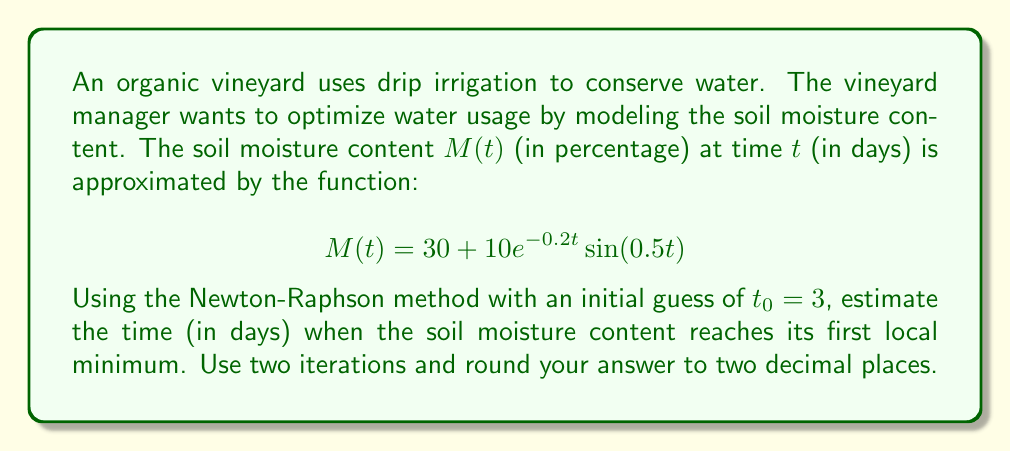Provide a solution to this math problem. To find the local minimum, we need to find where the derivative of $M(t)$ equals zero. Let's follow these steps:

1) First, we calculate $M'(t)$:
   $$M'(t) = 10e^{-0.2t}(0.5\cos(0.5t) - 0.2\sin(0.5t))$$

2) We want to find $t$ where $M'(t) = 0$. Let's define $f(t) = M'(t)$:
   $$f(t) = 10e^{-0.2t}(0.5\cos(0.5t) - 0.2\sin(0.5t))$$

3) We also need $f'(t)$:
   $$f'(t) = 10e^{-0.2t}(-0.2(0.5\cos(0.5t) - 0.2\sin(0.5t)) + (-0.25\sin(0.5t) - 0.1\cos(0.5t)))$$

4) The Newton-Raphson formula is:
   $$t_{n+1} = t_n - \frac{f(t_n)}{f'(t_n)}$$

5) First iteration:
   $t_0 = 3$
   $f(3) = 10e^{-0.6}(0.5\cos(1.5) - 0.2\sin(1.5)) \approx 1.3745$
   $f'(3) = 10e^{-0.6}(-0.2(0.5\cos(1.5) - 0.2\sin(1.5)) + (-0.25\sin(1.5) - 0.1\cos(1.5))) \approx -2.7490$
   
   $t_1 = 3 - \frac{1.3745}{-2.7490} \approx 3.5000$

6) Second iteration:
   $f(3.5) = 10e^{-0.7}(0.5\cos(1.75) - 0.2\sin(1.75)) \approx 0.0505$
   $f'(3.5) = 10e^{-0.7}(-0.2(0.5\cos(1.75) - 0.2\sin(1.75)) + (-0.25\sin(1.75) - 0.1\cos(1.75))) \approx -2.4975$
   
   $t_2 = 3.5 - \frac{0.0505}{-2.4975} \approx 3.5202$

7) Rounding to two decimal places, we get 3.52 days.
Answer: 3.52 days 